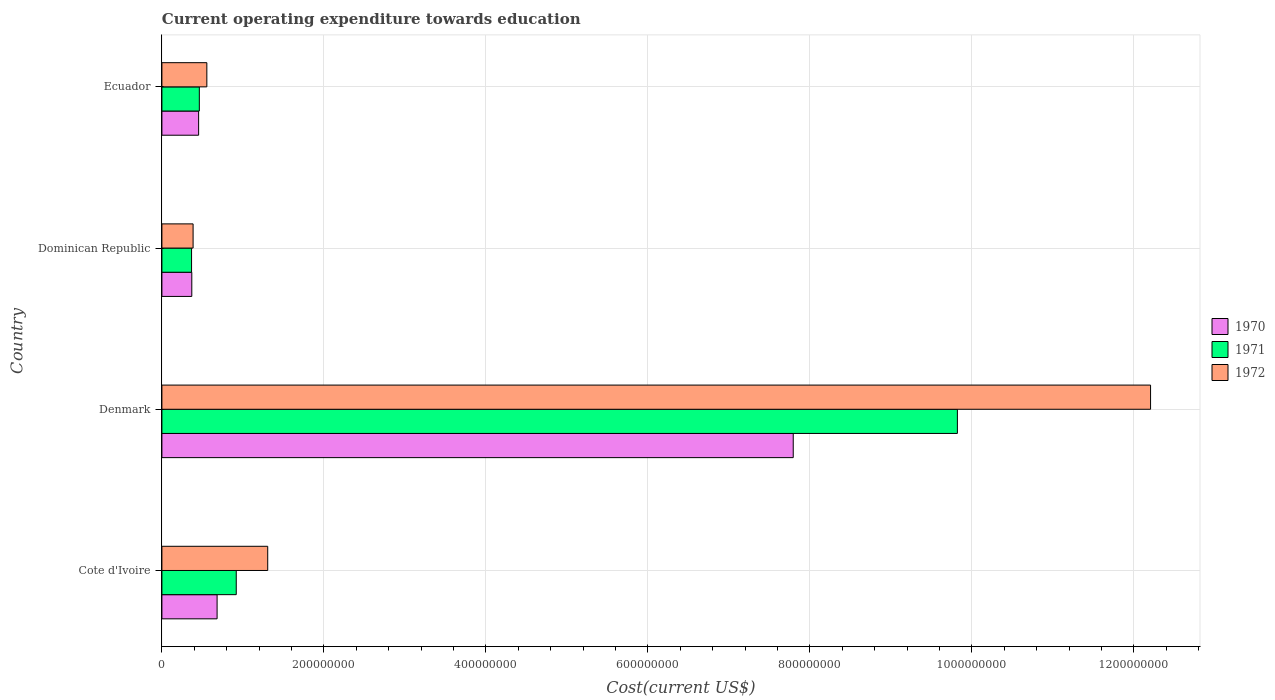How many groups of bars are there?
Provide a succinct answer. 4. Are the number of bars per tick equal to the number of legend labels?
Provide a short and direct response. Yes. Are the number of bars on each tick of the Y-axis equal?
Offer a very short reply. Yes. How many bars are there on the 4th tick from the top?
Your answer should be compact. 3. How many bars are there on the 1st tick from the bottom?
Keep it short and to the point. 3. What is the label of the 2nd group of bars from the top?
Your answer should be compact. Dominican Republic. In how many cases, is the number of bars for a given country not equal to the number of legend labels?
Ensure brevity in your answer.  0. What is the expenditure towards education in 1971 in Denmark?
Make the answer very short. 9.82e+08. Across all countries, what is the maximum expenditure towards education in 1970?
Your response must be concise. 7.79e+08. Across all countries, what is the minimum expenditure towards education in 1970?
Your answer should be compact. 3.69e+07. In which country was the expenditure towards education in 1971 maximum?
Keep it short and to the point. Denmark. In which country was the expenditure towards education in 1970 minimum?
Provide a succinct answer. Dominican Republic. What is the total expenditure towards education in 1972 in the graph?
Make the answer very short. 1.45e+09. What is the difference between the expenditure towards education in 1972 in Denmark and that in Dominican Republic?
Offer a terse response. 1.18e+09. What is the difference between the expenditure towards education in 1970 in Cote d'Ivoire and the expenditure towards education in 1972 in Dominican Republic?
Provide a succinct answer. 2.96e+07. What is the average expenditure towards education in 1971 per country?
Offer a very short reply. 2.89e+08. What is the difference between the expenditure towards education in 1972 and expenditure towards education in 1971 in Denmark?
Offer a terse response. 2.38e+08. What is the ratio of the expenditure towards education in 1971 in Cote d'Ivoire to that in Dominican Republic?
Give a very brief answer. 2.51. Is the difference between the expenditure towards education in 1972 in Denmark and Dominican Republic greater than the difference between the expenditure towards education in 1971 in Denmark and Dominican Republic?
Ensure brevity in your answer.  Yes. What is the difference between the highest and the second highest expenditure towards education in 1970?
Your answer should be very brief. 7.11e+08. What is the difference between the highest and the lowest expenditure towards education in 1971?
Make the answer very short. 9.45e+08. In how many countries, is the expenditure towards education in 1970 greater than the average expenditure towards education in 1970 taken over all countries?
Provide a succinct answer. 1. Is it the case that in every country, the sum of the expenditure towards education in 1972 and expenditure towards education in 1970 is greater than the expenditure towards education in 1971?
Keep it short and to the point. Yes. How many countries are there in the graph?
Provide a succinct answer. 4. What is the difference between two consecutive major ticks on the X-axis?
Your answer should be compact. 2.00e+08. Are the values on the major ticks of X-axis written in scientific E-notation?
Provide a succinct answer. No. Does the graph contain grids?
Your answer should be very brief. Yes. Where does the legend appear in the graph?
Make the answer very short. Center right. How many legend labels are there?
Ensure brevity in your answer.  3. How are the legend labels stacked?
Provide a short and direct response. Vertical. What is the title of the graph?
Your answer should be compact. Current operating expenditure towards education. What is the label or title of the X-axis?
Give a very brief answer. Cost(current US$). What is the Cost(current US$) of 1970 in Cote d'Ivoire?
Provide a short and direct response. 6.81e+07. What is the Cost(current US$) of 1971 in Cote d'Ivoire?
Ensure brevity in your answer.  9.18e+07. What is the Cost(current US$) in 1972 in Cote d'Ivoire?
Give a very brief answer. 1.31e+08. What is the Cost(current US$) of 1970 in Denmark?
Your answer should be compact. 7.79e+08. What is the Cost(current US$) of 1971 in Denmark?
Provide a succinct answer. 9.82e+08. What is the Cost(current US$) of 1972 in Denmark?
Give a very brief answer. 1.22e+09. What is the Cost(current US$) of 1970 in Dominican Republic?
Make the answer very short. 3.69e+07. What is the Cost(current US$) of 1971 in Dominican Republic?
Make the answer very short. 3.66e+07. What is the Cost(current US$) of 1972 in Dominican Republic?
Provide a succinct answer. 3.85e+07. What is the Cost(current US$) of 1970 in Ecuador?
Keep it short and to the point. 4.53e+07. What is the Cost(current US$) of 1971 in Ecuador?
Ensure brevity in your answer.  4.62e+07. What is the Cost(current US$) in 1972 in Ecuador?
Offer a very short reply. 5.55e+07. Across all countries, what is the maximum Cost(current US$) of 1970?
Make the answer very short. 7.79e+08. Across all countries, what is the maximum Cost(current US$) of 1971?
Make the answer very short. 9.82e+08. Across all countries, what is the maximum Cost(current US$) of 1972?
Make the answer very short. 1.22e+09. Across all countries, what is the minimum Cost(current US$) in 1970?
Your answer should be compact. 3.69e+07. Across all countries, what is the minimum Cost(current US$) in 1971?
Your response must be concise. 3.66e+07. Across all countries, what is the minimum Cost(current US$) in 1972?
Your response must be concise. 3.85e+07. What is the total Cost(current US$) in 1970 in the graph?
Your response must be concise. 9.30e+08. What is the total Cost(current US$) of 1971 in the graph?
Provide a succinct answer. 1.16e+09. What is the total Cost(current US$) of 1972 in the graph?
Offer a terse response. 1.45e+09. What is the difference between the Cost(current US$) of 1970 in Cote d'Ivoire and that in Denmark?
Offer a very short reply. -7.11e+08. What is the difference between the Cost(current US$) in 1971 in Cote d'Ivoire and that in Denmark?
Your answer should be very brief. -8.90e+08. What is the difference between the Cost(current US$) in 1972 in Cote d'Ivoire and that in Denmark?
Provide a succinct answer. -1.09e+09. What is the difference between the Cost(current US$) of 1970 in Cote d'Ivoire and that in Dominican Republic?
Give a very brief answer. 3.12e+07. What is the difference between the Cost(current US$) of 1971 in Cote d'Ivoire and that in Dominican Republic?
Provide a short and direct response. 5.52e+07. What is the difference between the Cost(current US$) of 1972 in Cote d'Ivoire and that in Dominican Republic?
Keep it short and to the point. 9.21e+07. What is the difference between the Cost(current US$) of 1970 in Cote d'Ivoire and that in Ecuador?
Your answer should be very brief. 2.28e+07. What is the difference between the Cost(current US$) of 1971 in Cote d'Ivoire and that in Ecuador?
Make the answer very short. 4.56e+07. What is the difference between the Cost(current US$) in 1972 in Cote d'Ivoire and that in Ecuador?
Give a very brief answer. 7.51e+07. What is the difference between the Cost(current US$) in 1970 in Denmark and that in Dominican Republic?
Make the answer very short. 7.43e+08. What is the difference between the Cost(current US$) of 1971 in Denmark and that in Dominican Republic?
Your response must be concise. 9.45e+08. What is the difference between the Cost(current US$) in 1972 in Denmark and that in Dominican Republic?
Your response must be concise. 1.18e+09. What is the difference between the Cost(current US$) of 1970 in Denmark and that in Ecuador?
Your answer should be compact. 7.34e+08. What is the difference between the Cost(current US$) in 1971 in Denmark and that in Ecuador?
Keep it short and to the point. 9.36e+08. What is the difference between the Cost(current US$) in 1972 in Denmark and that in Ecuador?
Your answer should be compact. 1.17e+09. What is the difference between the Cost(current US$) in 1970 in Dominican Republic and that in Ecuador?
Make the answer very short. -8.43e+06. What is the difference between the Cost(current US$) in 1971 in Dominican Republic and that in Ecuador?
Your answer should be very brief. -9.60e+06. What is the difference between the Cost(current US$) of 1972 in Dominican Republic and that in Ecuador?
Offer a very short reply. -1.70e+07. What is the difference between the Cost(current US$) of 1970 in Cote d'Ivoire and the Cost(current US$) of 1971 in Denmark?
Give a very brief answer. -9.14e+08. What is the difference between the Cost(current US$) in 1970 in Cote d'Ivoire and the Cost(current US$) in 1972 in Denmark?
Give a very brief answer. -1.15e+09. What is the difference between the Cost(current US$) of 1971 in Cote d'Ivoire and the Cost(current US$) of 1972 in Denmark?
Provide a short and direct response. -1.13e+09. What is the difference between the Cost(current US$) in 1970 in Cote d'Ivoire and the Cost(current US$) in 1971 in Dominican Republic?
Provide a succinct answer. 3.15e+07. What is the difference between the Cost(current US$) in 1970 in Cote d'Ivoire and the Cost(current US$) in 1972 in Dominican Republic?
Make the answer very short. 2.96e+07. What is the difference between the Cost(current US$) in 1971 in Cote d'Ivoire and the Cost(current US$) in 1972 in Dominican Republic?
Offer a very short reply. 5.33e+07. What is the difference between the Cost(current US$) in 1970 in Cote d'Ivoire and the Cost(current US$) in 1971 in Ecuador?
Keep it short and to the point. 2.19e+07. What is the difference between the Cost(current US$) in 1970 in Cote d'Ivoire and the Cost(current US$) in 1972 in Ecuador?
Give a very brief answer. 1.27e+07. What is the difference between the Cost(current US$) of 1971 in Cote d'Ivoire and the Cost(current US$) of 1972 in Ecuador?
Your answer should be very brief. 3.63e+07. What is the difference between the Cost(current US$) of 1970 in Denmark and the Cost(current US$) of 1971 in Dominican Republic?
Your answer should be very brief. 7.43e+08. What is the difference between the Cost(current US$) of 1970 in Denmark and the Cost(current US$) of 1972 in Dominican Republic?
Your answer should be very brief. 7.41e+08. What is the difference between the Cost(current US$) of 1971 in Denmark and the Cost(current US$) of 1972 in Dominican Republic?
Keep it short and to the point. 9.44e+08. What is the difference between the Cost(current US$) in 1970 in Denmark and the Cost(current US$) in 1971 in Ecuador?
Keep it short and to the point. 7.33e+08. What is the difference between the Cost(current US$) of 1970 in Denmark and the Cost(current US$) of 1972 in Ecuador?
Provide a short and direct response. 7.24e+08. What is the difference between the Cost(current US$) of 1971 in Denmark and the Cost(current US$) of 1972 in Ecuador?
Ensure brevity in your answer.  9.27e+08. What is the difference between the Cost(current US$) in 1970 in Dominican Republic and the Cost(current US$) in 1971 in Ecuador?
Offer a very short reply. -9.31e+06. What is the difference between the Cost(current US$) in 1970 in Dominican Republic and the Cost(current US$) in 1972 in Ecuador?
Offer a terse response. -1.86e+07. What is the difference between the Cost(current US$) in 1971 in Dominican Republic and the Cost(current US$) in 1972 in Ecuador?
Your answer should be very brief. -1.89e+07. What is the average Cost(current US$) of 1970 per country?
Give a very brief answer. 2.32e+08. What is the average Cost(current US$) in 1971 per country?
Your answer should be very brief. 2.89e+08. What is the average Cost(current US$) in 1972 per country?
Give a very brief answer. 3.61e+08. What is the difference between the Cost(current US$) in 1970 and Cost(current US$) in 1971 in Cote d'Ivoire?
Keep it short and to the point. -2.37e+07. What is the difference between the Cost(current US$) of 1970 and Cost(current US$) of 1972 in Cote d'Ivoire?
Your answer should be very brief. -6.25e+07. What is the difference between the Cost(current US$) of 1971 and Cost(current US$) of 1972 in Cote d'Ivoire?
Provide a short and direct response. -3.88e+07. What is the difference between the Cost(current US$) of 1970 and Cost(current US$) of 1971 in Denmark?
Make the answer very short. -2.03e+08. What is the difference between the Cost(current US$) in 1970 and Cost(current US$) in 1972 in Denmark?
Your answer should be very brief. -4.41e+08. What is the difference between the Cost(current US$) in 1971 and Cost(current US$) in 1972 in Denmark?
Your answer should be very brief. -2.38e+08. What is the difference between the Cost(current US$) in 1970 and Cost(current US$) in 1971 in Dominican Republic?
Provide a succinct answer. 2.90e+05. What is the difference between the Cost(current US$) in 1970 and Cost(current US$) in 1972 in Dominican Republic?
Offer a very short reply. -1.61e+06. What is the difference between the Cost(current US$) in 1971 and Cost(current US$) in 1972 in Dominican Republic?
Keep it short and to the point. -1.90e+06. What is the difference between the Cost(current US$) in 1970 and Cost(current US$) in 1971 in Ecuador?
Provide a succinct answer. -8.82e+05. What is the difference between the Cost(current US$) in 1970 and Cost(current US$) in 1972 in Ecuador?
Make the answer very short. -1.02e+07. What is the difference between the Cost(current US$) in 1971 and Cost(current US$) in 1972 in Ecuador?
Your response must be concise. -9.27e+06. What is the ratio of the Cost(current US$) in 1970 in Cote d'Ivoire to that in Denmark?
Offer a very short reply. 0.09. What is the ratio of the Cost(current US$) of 1971 in Cote d'Ivoire to that in Denmark?
Your answer should be compact. 0.09. What is the ratio of the Cost(current US$) in 1972 in Cote d'Ivoire to that in Denmark?
Your answer should be compact. 0.11. What is the ratio of the Cost(current US$) in 1970 in Cote d'Ivoire to that in Dominican Republic?
Your response must be concise. 1.85. What is the ratio of the Cost(current US$) in 1971 in Cote d'Ivoire to that in Dominican Republic?
Offer a very short reply. 2.51. What is the ratio of the Cost(current US$) in 1972 in Cote d'Ivoire to that in Dominican Republic?
Your answer should be very brief. 3.39. What is the ratio of the Cost(current US$) in 1970 in Cote d'Ivoire to that in Ecuador?
Offer a terse response. 1.5. What is the ratio of the Cost(current US$) in 1971 in Cote d'Ivoire to that in Ecuador?
Your answer should be compact. 1.99. What is the ratio of the Cost(current US$) of 1972 in Cote d'Ivoire to that in Ecuador?
Provide a short and direct response. 2.35. What is the ratio of the Cost(current US$) of 1970 in Denmark to that in Dominican Republic?
Your answer should be very brief. 21.12. What is the ratio of the Cost(current US$) of 1971 in Denmark to that in Dominican Republic?
Your answer should be very brief. 26.82. What is the ratio of the Cost(current US$) of 1972 in Denmark to that in Dominican Republic?
Ensure brevity in your answer.  31.69. What is the ratio of the Cost(current US$) in 1970 in Denmark to that in Ecuador?
Give a very brief answer. 17.19. What is the ratio of the Cost(current US$) of 1971 in Denmark to that in Ecuador?
Make the answer very short. 21.25. What is the ratio of the Cost(current US$) in 1972 in Denmark to that in Ecuador?
Provide a succinct answer. 22. What is the ratio of the Cost(current US$) in 1970 in Dominican Republic to that in Ecuador?
Your answer should be very brief. 0.81. What is the ratio of the Cost(current US$) in 1971 in Dominican Republic to that in Ecuador?
Offer a very short reply. 0.79. What is the ratio of the Cost(current US$) of 1972 in Dominican Republic to that in Ecuador?
Your answer should be compact. 0.69. What is the difference between the highest and the second highest Cost(current US$) in 1970?
Your answer should be compact. 7.11e+08. What is the difference between the highest and the second highest Cost(current US$) in 1971?
Provide a short and direct response. 8.90e+08. What is the difference between the highest and the second highest Cost(current US$) of 1972?
Your answer should be compact. 1.09e+09. What is the difference between the highest and the lowest Cost(current US$) in 1970?
Your answer should be compact. 7.43e+08. What is the difference between the highest and the lowest Cost(current US$) in 1971?
Offer a terse response. 9.45e+08. What is the difference between the highest and the lowest Cost(current US$) of 1972?
Make the answer very short. 1.18e+09. 